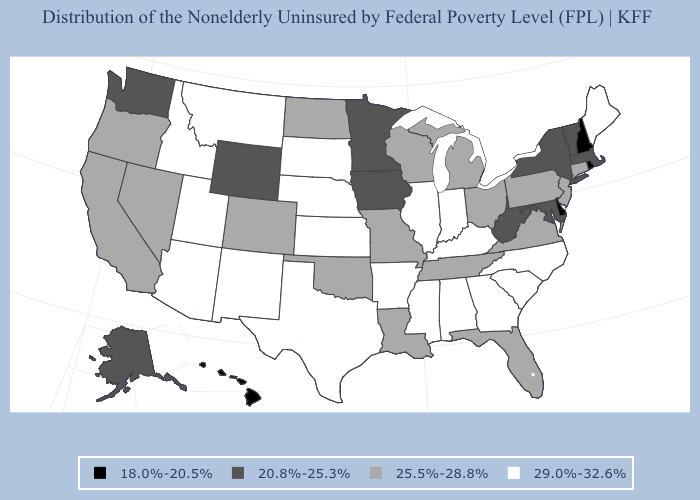Name the states that have a value in the range 18.0%-20.5%?
Answer briefly. Delaware, Hawaii, New Hampshire, Rhode Island. What is the lowest value in the Northeast?
Concise answer only. 18.0%-20.5%. Which states have the highest value in the USA?
Give a very brief answer. Alabama, Arizona, Arkansas, Georgia, Idaho, Illinois, Indiana, Kansas, Kentucky, Maine, Mississippi, Montana, Nebraska, New Mexico, North Carolina, South Carolina, South Dakota, Texas, Utah. Name the states that have a value in the range 18.0%-20.5%?
Keep it brief. Delaware, Hawaii, New Hampshire, Rhode Island. Does New Hampshire have the lowest value in the Northeast?
Be succinct. Yes. What is the highest value in the Northeast ?
Give a very brief answer. 29.0%-32.6%. Does Delaware have the lowest value in the South?
Answer briefly. Yes. Which states have the lowest value in the USA?
Write a very short answer. Delaware, Hawaii, New Hampshire, Rhode Island. Name the states that have a value in the range 18.0%-20.5%?
Answer briefly. Delaware, Hawaii, New Hampshire, Rhode Island. Does New Hampshire have a lower value than Rhode Island?
Quick response, please. No. What is the highest value in the South ?
Give a very brief answer. 29.0%-32.6%. What is the lowest value in the West?
Keep it brief. 18.0%-20.5%. What is the lowest value in states that border Massachusetts?
Give a very brief answer. 18.0%-20.5%. Name the states that have a value in the range 18.0%-20.5%?
Keep it brief. Delaware, Hawaii, New Hampshire, Rhode Island. Which states hav the highest value in the West?
Quick response, please. Arizona, Idaho, Montana, New Mexico, Utah. 